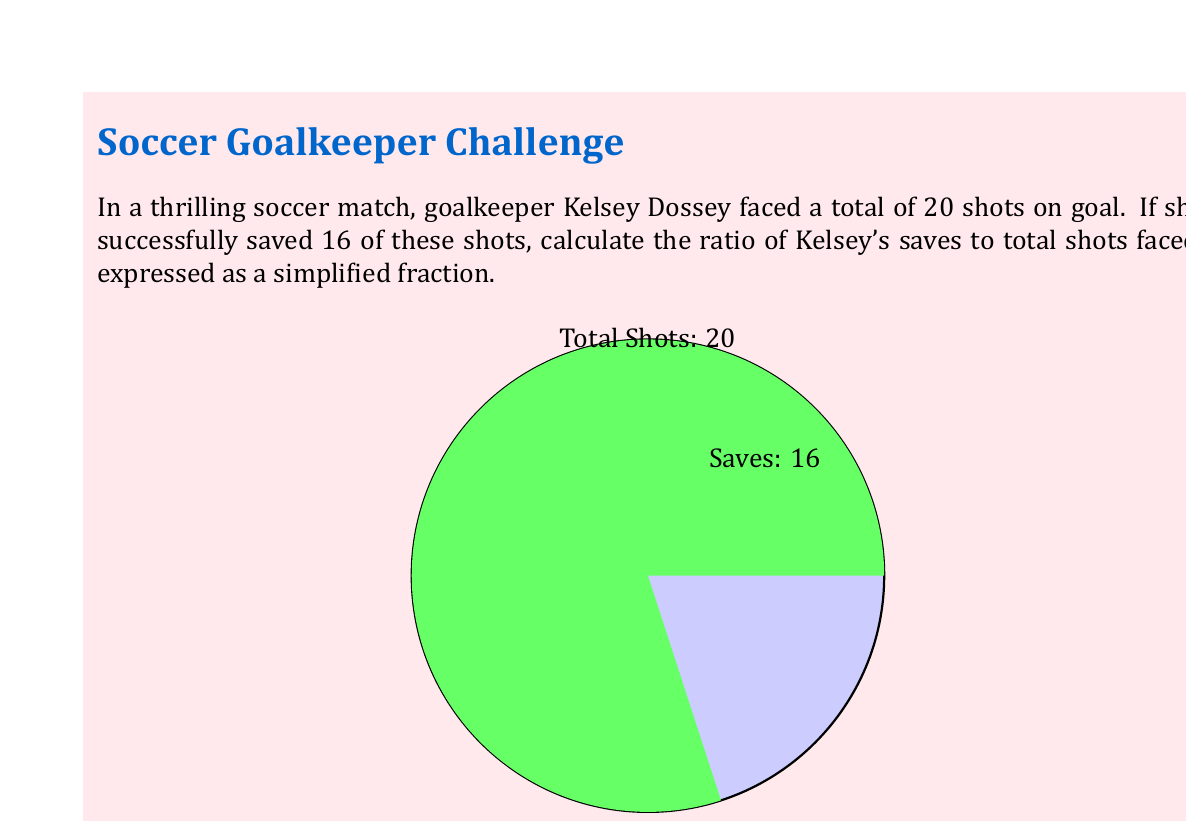Help me with this question. Let's approach this step-by-step:

1) First, let's identify the key information:
   - Total shots faced: 20
   - Saves made: 16

2) The ratio of saves to total shots is represented as:
   
   $$\frac{\text{Number of Saves}}{\text{Total Shots Faced}}$$

3) Substituting our values:

   $$\frac{16}{20}$$

4) To simplify this fraction, we need to find the greatest common divisor (GCD) of 16 and 20:
   
   $GCD(16,20) = 4$

5) Dividing both the numerator and denominator by 4:

   $$\frac{16 \div 4}{20 \div 4} = \frac{4}{5}$$

Thus, the simplified ratio of Kelsey Dossey's saves to total shots faced is $\frac{4}{5}$.
Answer: $\frac{4}{5}$ 